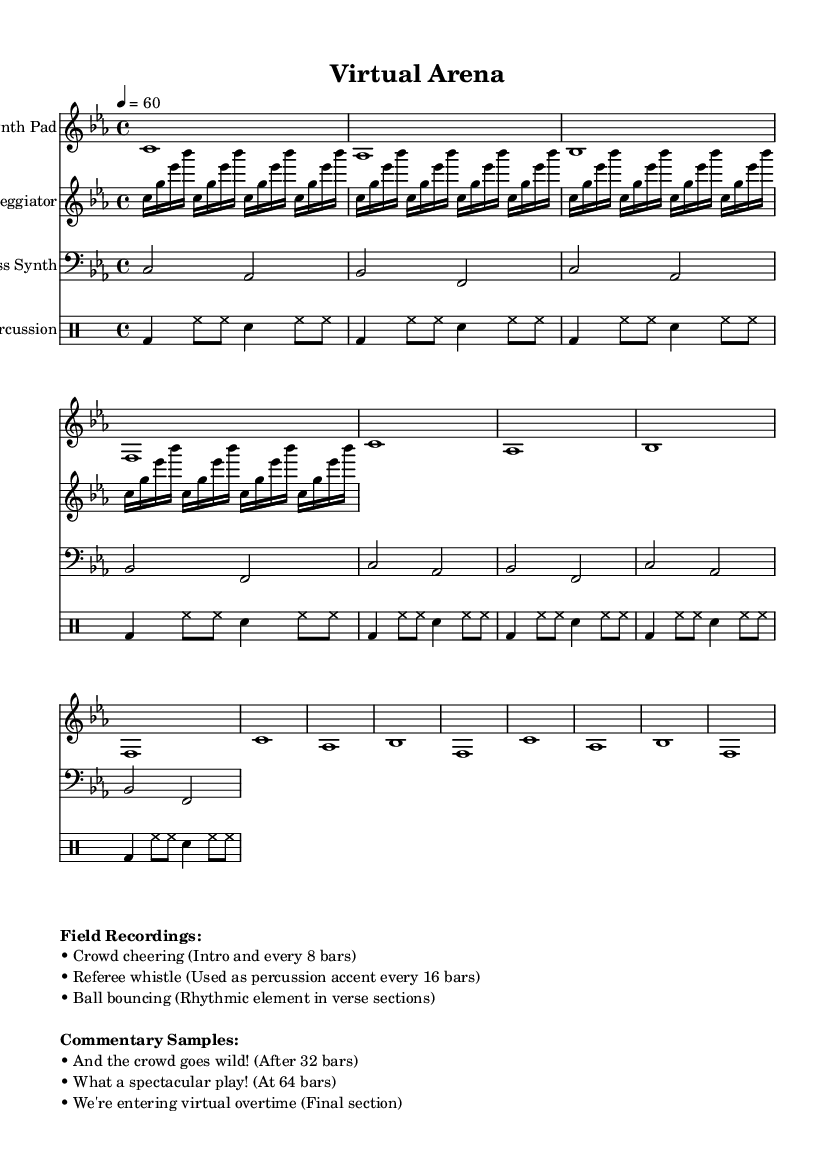What is the key signature of this music? The key signature is C minor, which has three flats: B-flat, E-flat, and A-flat. This can be determined by looking at the global section at the beginning of the score.
Answer: C minor What is the time signature of this piece? The time signature is 4/4, indicated in the global section of the score. This means there are four beats in every measure, and each quarter note receives one beat.
Answer: 4/4 What is the tempo marking in this score? The tempo marking is 60 beats per minute, noted in the global section. This indicates how fast the piece should be played.
Answer: 60 How many measures are included in the synth pad section? The synth pad section consists of 4 measures, as indicated by the repeated pattern in the synthPad definition. Each repeat unfolds into a whole note lasting for one measure.
Answer: 4 What type of sound does the "Arpeggiator" create? The arpeggiator creates a sequence of notes played in succession, which can be inferred from the pattern seen in the arpeggiator section as it moves through the notes. This type of sound contributes a melodic flow typical in ambient electronic music.
Answer: Melodic flow Where are the crowd cheering samples introduced in the score? The crowd cheering samples are introduced in the intro and repeated every 8 bars, as noted in the markup section detailing field recordings. This provides a performance cue for integration within the overall sound.
Answer: Intro and every 8 bars What is the purpose of including commentary samples in the composition? The commentary samples are used to enhance the thematic elements of sports commentary, enriching the narrative of the piece and connecting the sound to sports culture. Each sample is strategically placed to emphasize key moments in the music.
Answer: Enhance thematic elements 